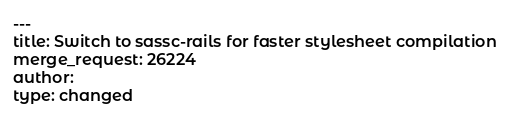Convert code to text. <code><loc_0><loc_0><loc_500><loc_500><_YAML_>---
title: Switch to sassc-rails for faster stylesheet compilation
merge_request: 26224
author:
type: changed
</code> 